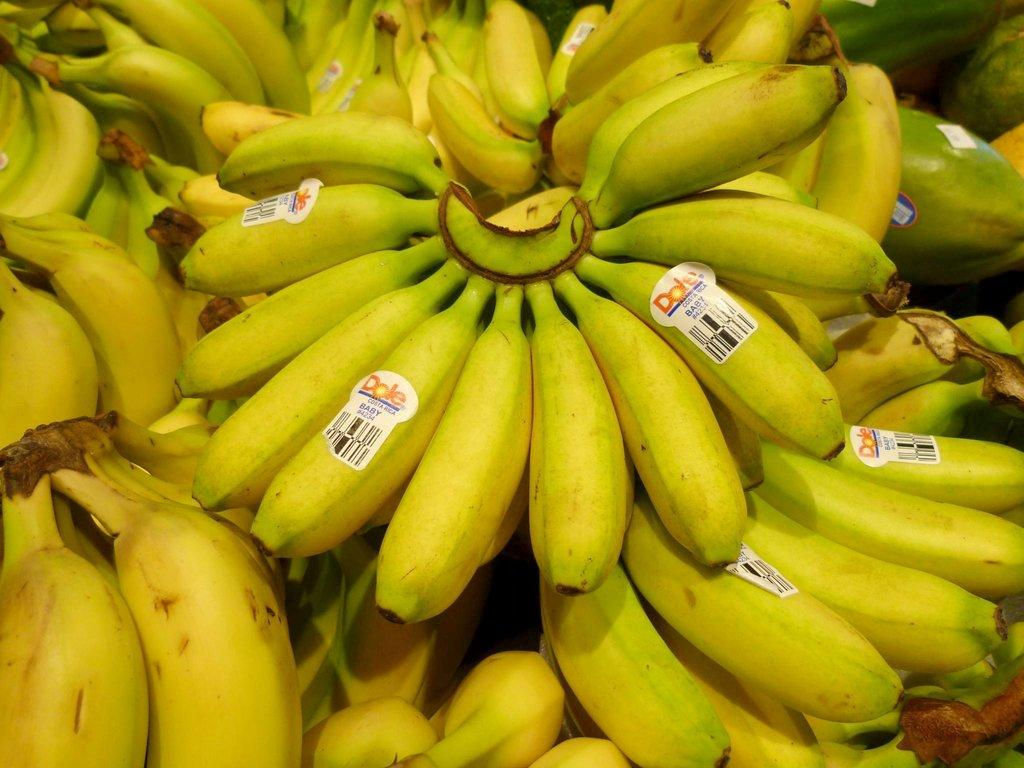What type of fruit is visible in the image? There are ripe bananas in the image. Is there any additional information about the bananas? Yes, there is a label pasted on the bananas. What other fruit can be seen in the image? There is another fruit on the right side of the image. Is there any quicksand visible in the image? No, there is no quicksand present in the image. What type of pocket is featured on the bananas? There are no pockets on the bananas, as they are a type of fruit. 